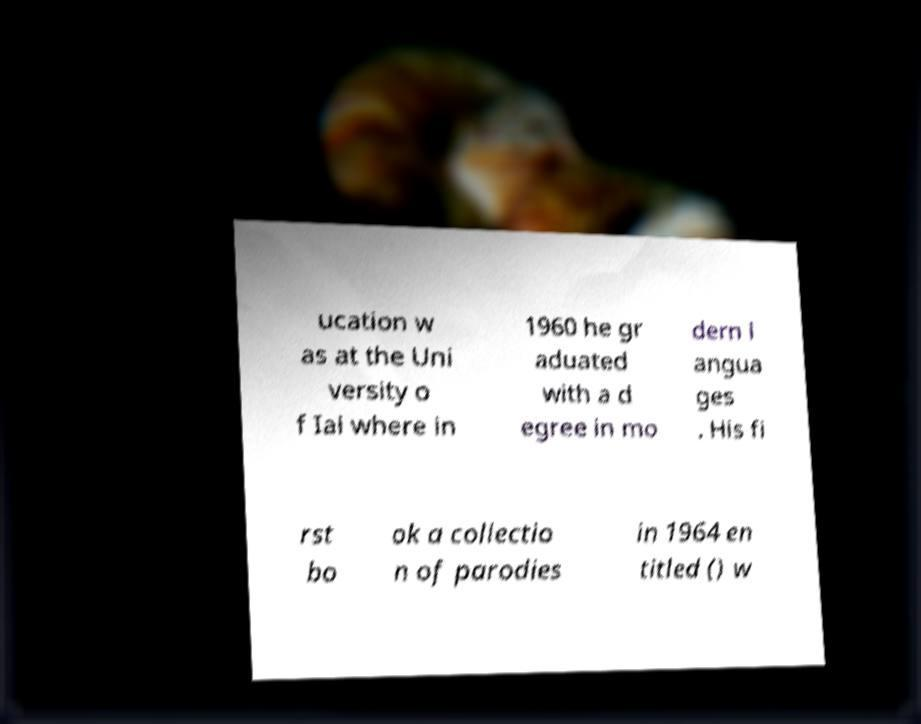Could you assist in decoding the text presented in this image and type it out clearly? ucation w as at the Uni versity o f Iai where in 1960 he gr aduated with a d egree in mo dern l angua ges . His fi rst bo ok a collectio n of parodies in 1964 en titled () w 